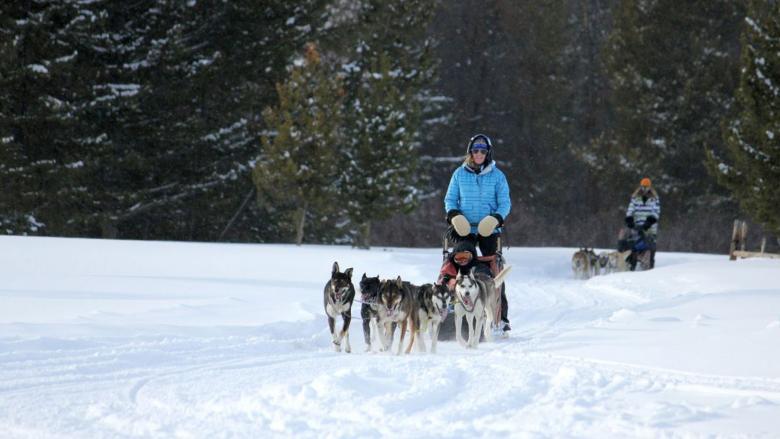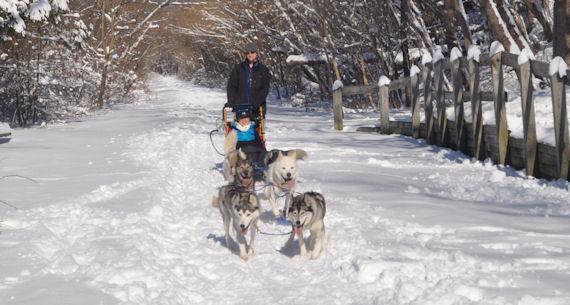The first image is the image on the left, the second image is the image on the right. Assess this claim about the two images: "An image shows a sled driver standing behind an empty sled, and only two visible dogs pulling it.". Correct or not? Answer yes or no. No. The first image is the image on the left, the second image is the image on the right. Given the left and right images, does the statement "All the sleds are pointing to the left." hold true? Answer yes or no. No. 